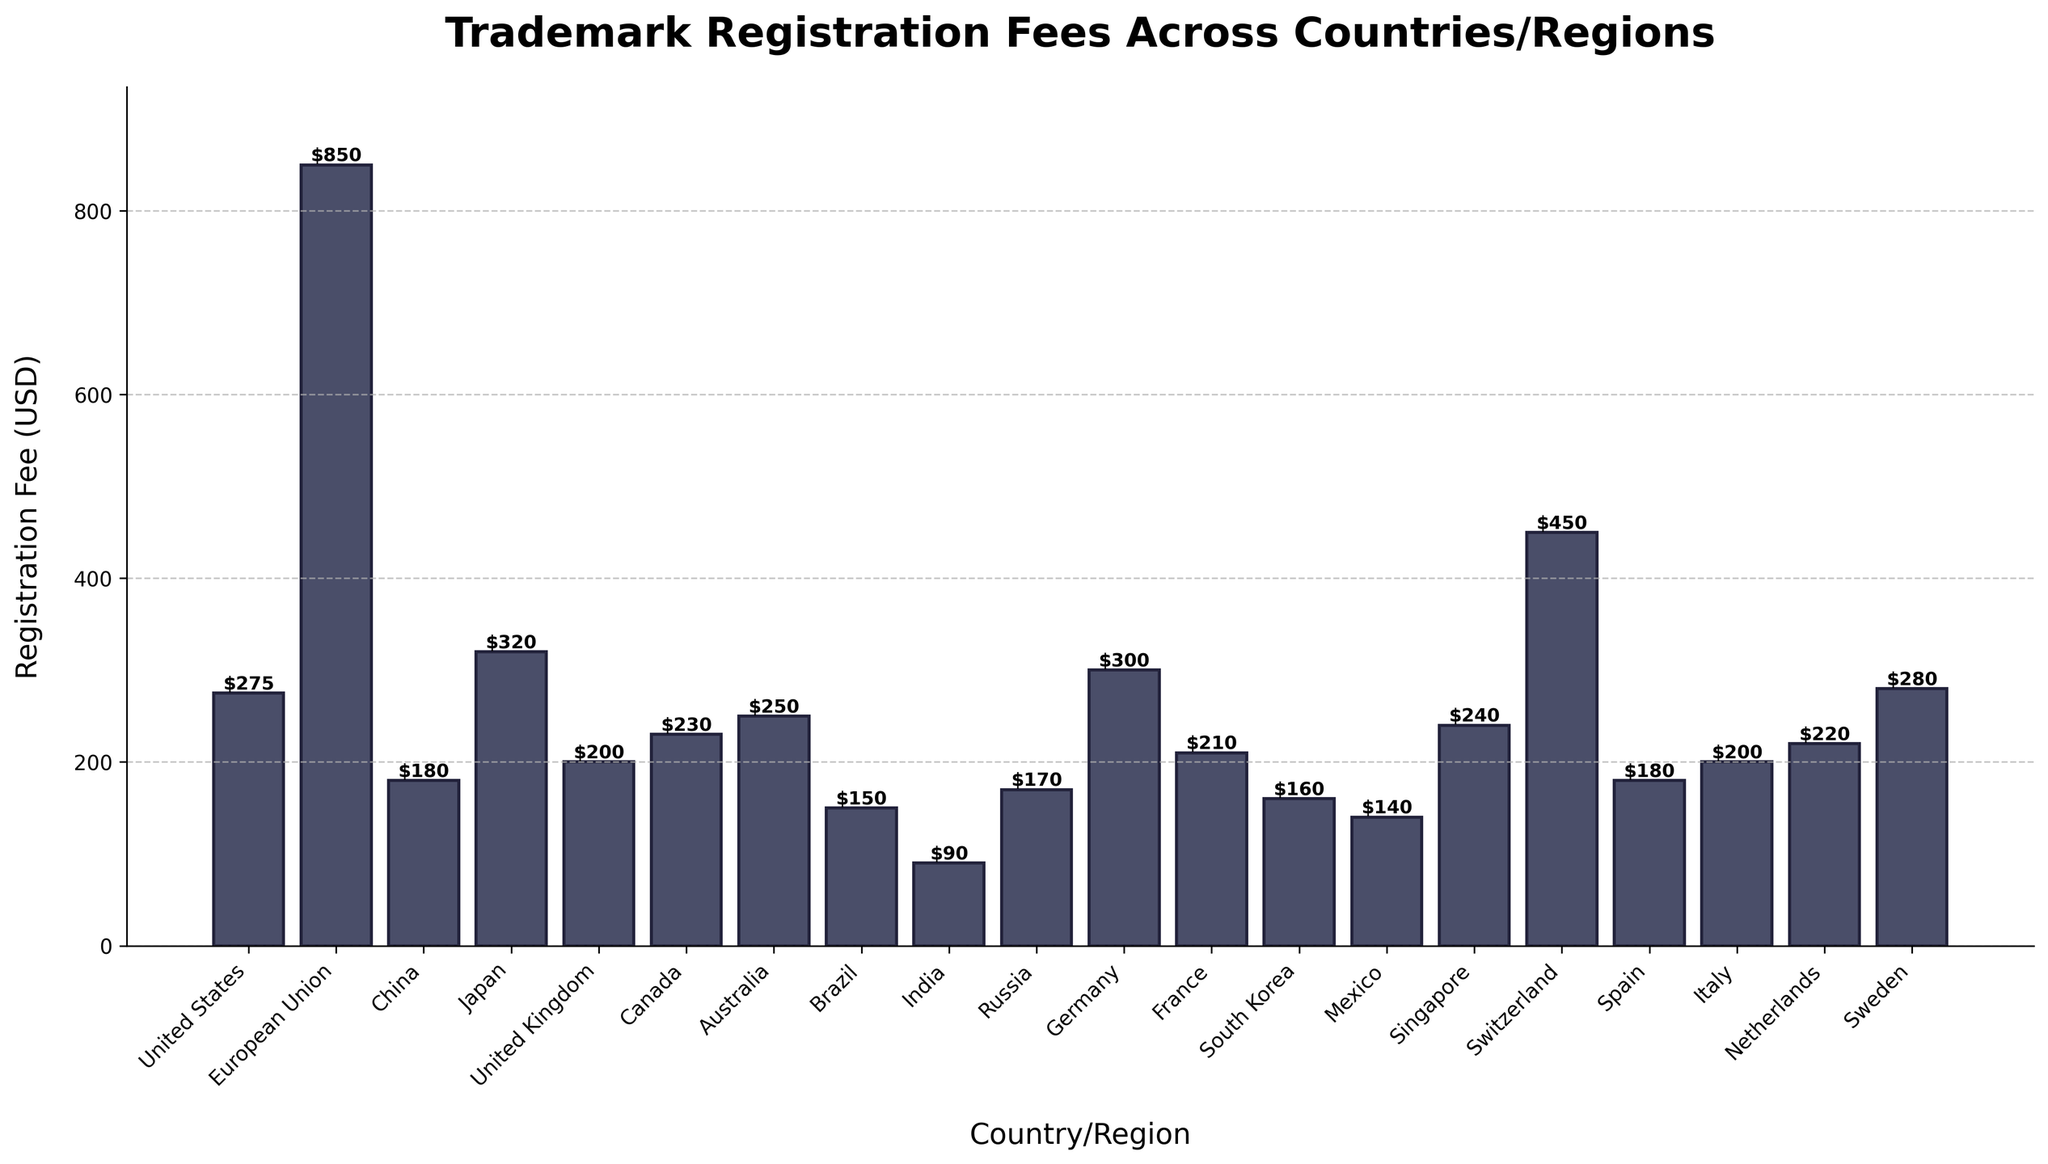What are the top 3 countries/regions with the highest trademark registration fees? First, identify the bars with the highest values in the plot. The top three highest registration fees are in the European Union ($850), Switzerland ($450), and the United States ($275).
Answer: European Union, Switzerland, United States Which country/region has the lowest trademark registration fee? Look for the bar with the smallest height. The country with the lowest fee has a value of $90, which is India.
Answer: India How much more expensive is trademark registration in the European Union than in Canada? Find the fees for the European Union ($850) and Canada ($230). Subtract the Canadian fee from the European Union fee: $850 - $230 = $620.
Answer: $620 Between Japan and Germany, which has a higher registration fee, and by how much? Identify the fees for Japan ($320) and Germany ($300). Subtract Germany's fee from Japan's fee: $320 - $300 = $20. Japan has a higher fee by $20.
Answer: Japan, $20 What is the average trademark registration fee across all listed countries/regions? Sum all the fees from the plot and divide by the number of countries/regions. Total sum: $275+$850+$180+$320+$200+$230+$250+$150+$90+$170+$300+$210+$160+$140+$240+$450+$180+$200+$220+$280 = $4995. Number of countries/regions: 20. Average fee: $4995 / 20 = $249.75.
Answer: $249.75 Which country/region has a trademark registration fee of $210? Look for the bar labeled with $210. The country is France.
Answer: France Is the registration fee in Australia higher or lower than in Russia? By how much? Find the fees for Australia ($250) and Russia ($170). Subtract Russia's fee from Australia's fee: $250 - $170 = $80. Australia's fee is higher by $80.
Answer: Higher, $80 How much higher is the trademark registration fee in South Korea compared to Mexico? Identify the fees for South Korea ($160) and Mexico ($140). Subtract Mexico's fee from South Korea's fee: $160 - $140 = $20. South Korea's fee is $20 higher.
Answer: $20 What is the combined registration fee for the United Kingdom and Singapore? Find the fees for the United Kingdom ($200) and Singapore ($240). Sum them up: $200 + $240 = $440.
Answer: $440 Which has a higher fee: Switzerland or the United States? And by how much? Identify the fees for Switzerland ($450) and the United States ($275). Subtract the United States fee from Switzerland's fee: $450 - $275 = $175. Switzerland's fee is higher by $175.
Answer: Switzerland, $175 